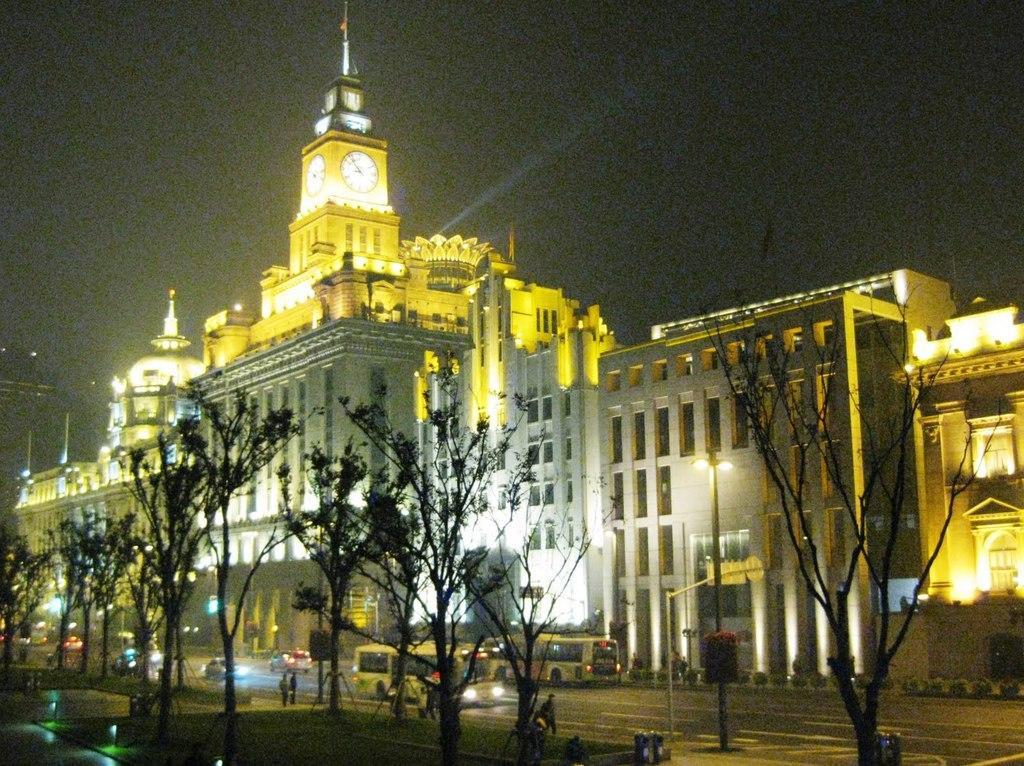Describe this image in one or two sentences. In this image there are buildings, in front of the buildings there are a few vehicles moving on the road and there are a few people walking, there are trees. The background is dark. On the one of the buildings there is a clock. 